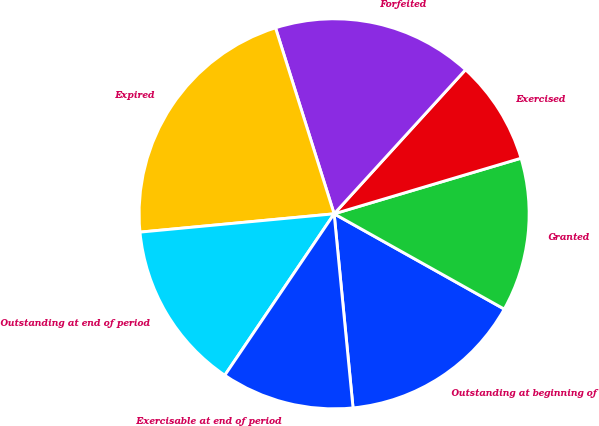Convert chart. <chart><loc_0><loc_0><loc_500><loc_500><pie_chart><fcel>Outstanding at beginning of<fcel>Granted<fcel>Exercised<fcel>Forfeited<fcel>Expired<fcel>Outstanding at end of period<fcel>Exercisable at end of period<nl><fcel>15.33%<fcel>12.73%<fcel>8.63%<fcel>16.63%<fcel>21.64%<fcel>14.03%<fcel>11.02%<nl></chart> 